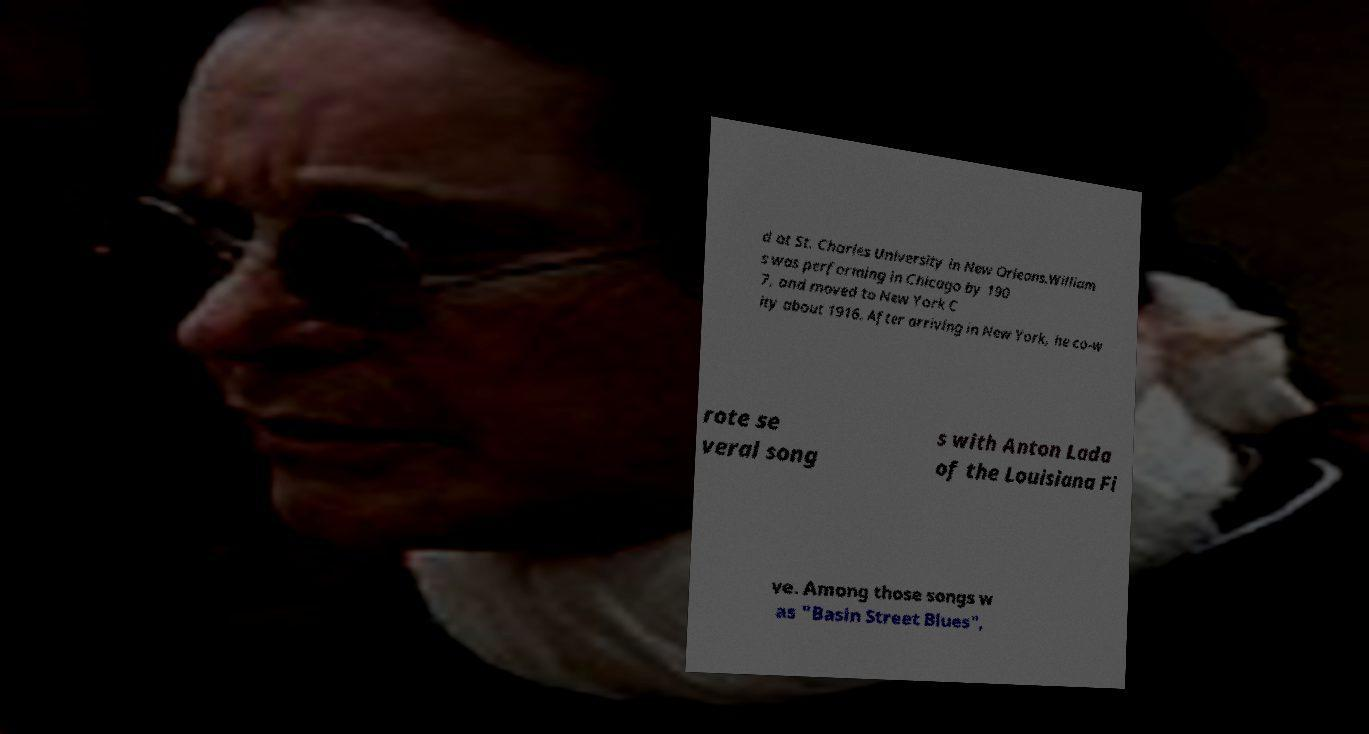Can you accurately transcribe the text from the provided image for me? d at St. Charles University in New Orleans.William s was performing in Chicago by 190 7, and moved to New York C ity about 1916. After arriving in New York, he co-w rote se veral song s with Anton Lada of the Louisiana Fi ve. Among those songs w as "Basin Street Blues", 